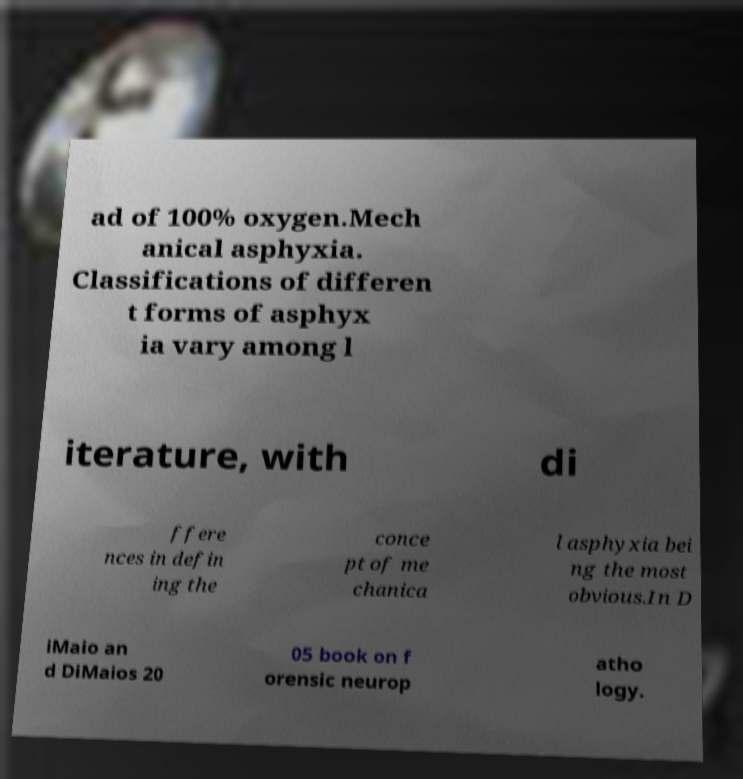Could you assist in decoding the text presented in this image and type it out clearly? ad of 100% oxygen.Mech anical asphyxia. Classifications of differen t forms of asphyx ia vary among l iterature, with di ffere nces in defin ing the conce pt of me chanica l asphyxia bei ng the most obvious.In D iMaio an d DiMaios 20 05 book on f orensic neurop atho logy. 